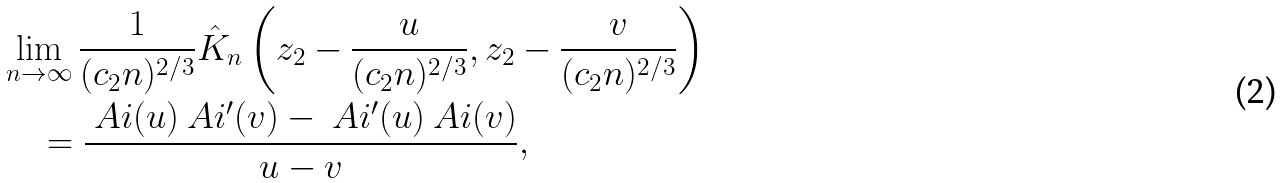<formula> <loc_0><loc_0><loc_500><loc_500>& \lim _ { n \to \infty } \frac { 1 } { ( c _ { 2 } n ) ^ { 2 / 3 } } \hat { K } _ { n } \left ( z _ { 2 } - \frac { u } { ( c _ { 2 } n ) ^ { 2 / 3 } } , z _ { 2 } - \frac { v } { ( c _ { 2 } n ) ^ { 2 / 3 } } \right ) \\ & \quad = \frac { \ A i ( u ) \ A i ^ { \prime } ( v ) - \ A i ^ { \prime } ( u ) \ A i ( v ) } { u - v } ,</formula> 